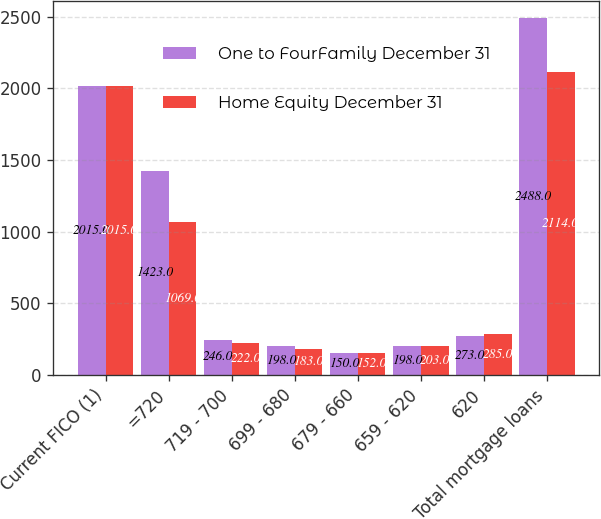Convert chart to OTSL. <chart><loc_0><loc_0><loc_500><loc_500><stacked_bar_chart><ecel><fcel>Current FICO (1)<fcel>=720<fcel>719 - 700<fcel>699 - 680<fcel>679 - 660<fcel>659 - 620<fcel>620<fcel>Total mortgage loans<nl><fcel>One to FourFamily December 31<fcel>2015<fcel>1423<fcel>246<fcel>198<fcel>150<fcel>198<fcel>273<fcel>2488<nl><fcel>Home Equity December 31<fcel>2015<fcel>1069<fcel>222<fcel>183<fcel>152<fcel>203<fcel>285<fcel>2114<nl></chart> 